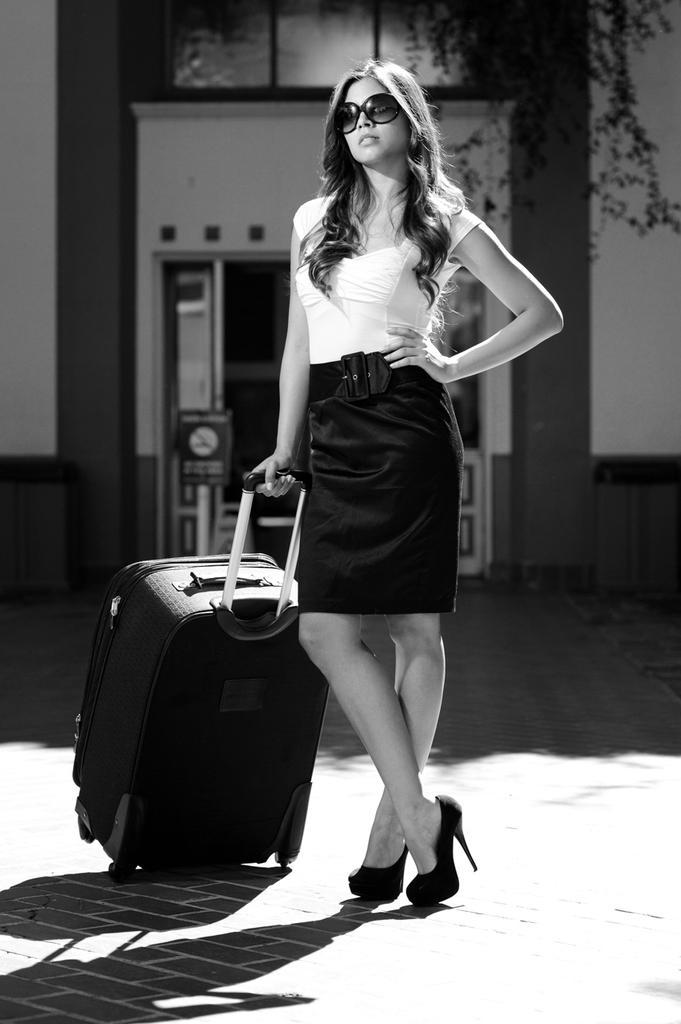In one or two sentences, can you explain what this image depicts? In the image in the center we can see one woman holding trolley. She is wearing glasses. Coming to the background we can see the building. 